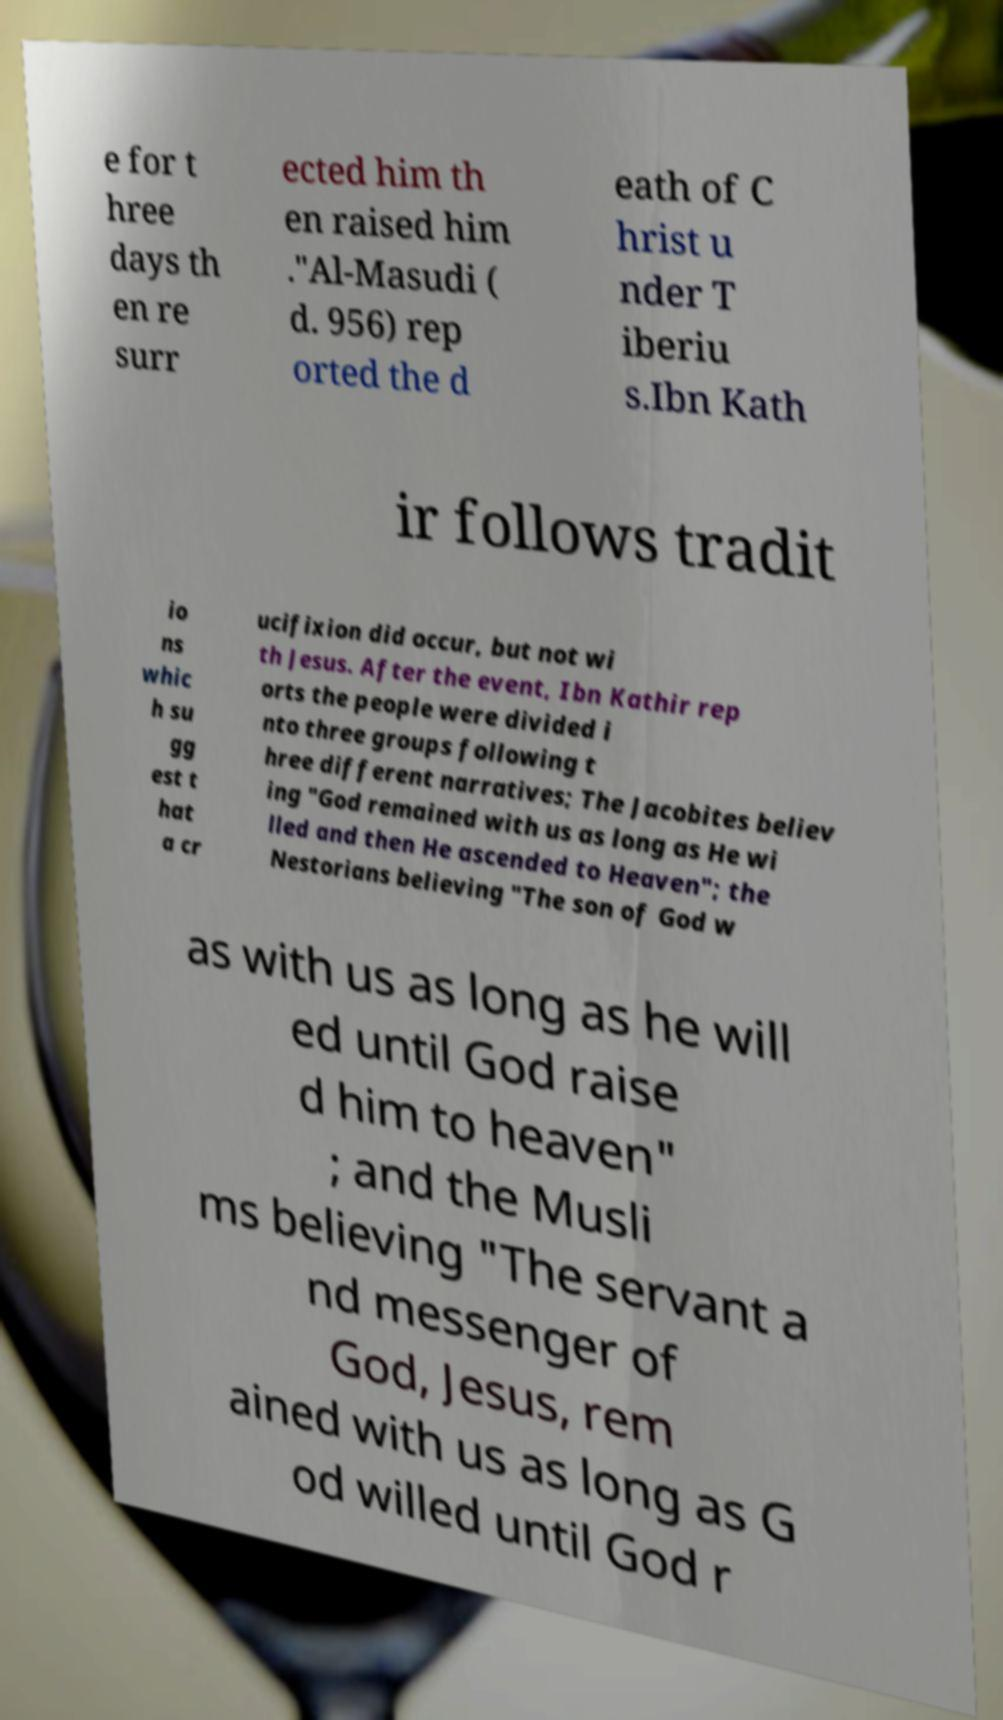Please read and relay the text visible in this image. What does it say? e for t hree days th en re surr ected him th en raised him ."Al-Masudi ( d. 956) rep orted the d eath of C hrist u nder T iberiu s.Ibn Kath ir follows tradit io ns whic h su gg est t hat a cr ucifixion did occur, but not wi th Jesus. After the event, Ibn Kathir rep orts the people were divided i nto three groups following t hree different narratives; The Jacobites believ ing "God remained with us as long as He wi lled and then He ascended to Heaven"; the Nestorians believing "The son of God w as with us as long as he will ed until God raise d him to heaven" ; and the Musli ms believing "The servant a nd messenger of God, Jesus, rem ained with us as long as G od willed until God r 